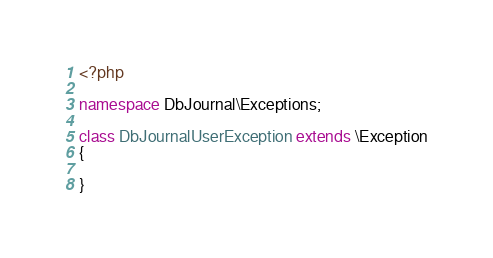Convert code to text. <code><loc_0><loc_0><loc_500><loc_500><_PHP_><?php

namespace DbJournal\Exceptions;

class DbJournalUserException extends \Exception
{

}
</code> 